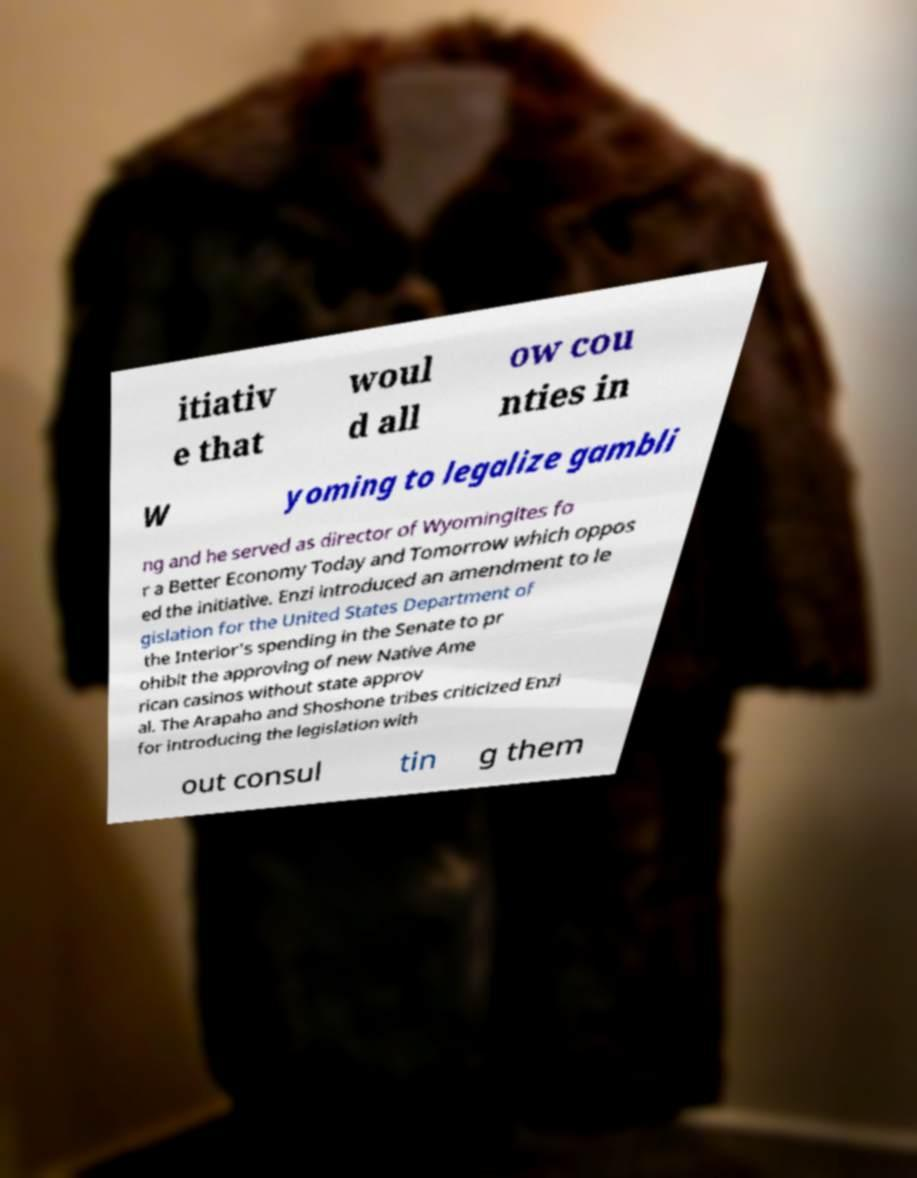For documentation purposes, I need the text within this image transcribed. Could you provide that? itiativ e that woul d all ow cou nties in W yoming to legalize gambli ng and he served as director of Wyomingites fo r a Better Economy Today and Tomorrow which oppos ed the initiative. Enzi introduced an amendment to le gislation for the United States Department of the Interior's spending in the Senate to pr ohibit the approving of new Native Ame rican casinos without state approv al. The Arapaho and Shoshone tribes criticized Enzi for introducing the legislation with out consul tin g them 